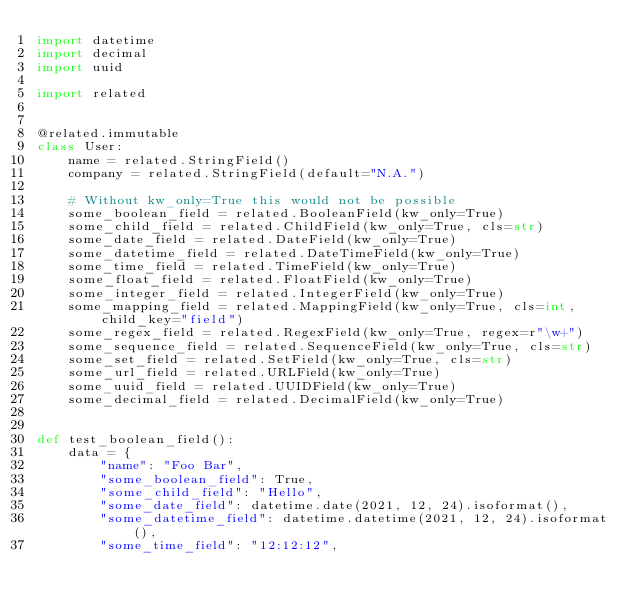<code> <loc_0><loc_0><loc_500><loc_500><_Python_>import datetime
import decimal
import uuid

import related


@related.immutable
class User:
    name = related.StringField()
    company = related.StringField(default="N.A.")

    # Without kw_only=True this would not be possible
    some_boolean_field = related.BooleanField(kw_only=True)
    some_child_field = related.ChildField(kw_only=True, cls=str)
    some_date_field = related.DateField(kw_only=True)
    some_datetime_field = related.DateTimeField(kw_only=True)
    some_time_field = related.TimeField(kw_only=True)
    some_float_field = related.FloatField(kw_only=True)
    some_integer_field = related.IntegerField(kw_only=True)
    some_mapping_field = related.MappingField(kw_only=True, cls=int, child_key="field")
    some_regex_field = related.RegexField(kw_only=True, regex=r"\w+")
    some_sequence_field = related.SequenceField(kw_only=True, cls=str)
    some_set_field = related.SetField(kw_only=True, cls=str)
    some_url_field = related.URLField(kw_only=True)
    some_uuid_field = related.UUIDField(kw_only=True)
    some_decimal_field = related.DecimalField(kw_only=True)


def test_boolean_field():
    data = {
        "name": "Foo Bar",
        "some_boolean_field": True,
        "some_child_field": "Hello",
        "some_date_field": datetime.date(2021, 12, 24).isoformat(),
        "some_datetime_field": datetime.datetime(2021, 12, 24).isoformat(),
        "some_time_field": "12:12:12",</code> 